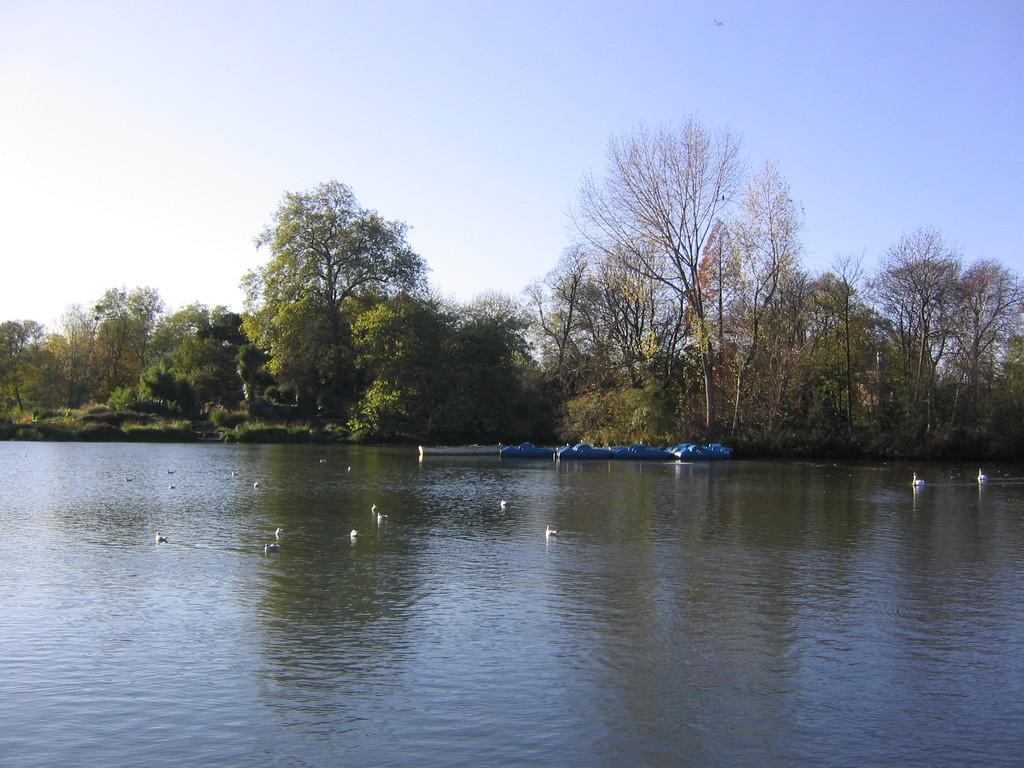What type of vehicles are present in the image? There are boats in the image. What other living creatures can be seen in the image? There are birds on the water in the image. What type of vegetation is visible in the background of the image? There are trees visible in the background of the image. How many mice are swimming in the stream in the image? There is no stream or mice present in the image. What type of belief system is depicted in the image? There is no depiction of a belief system in the image; it features boats and birds. 